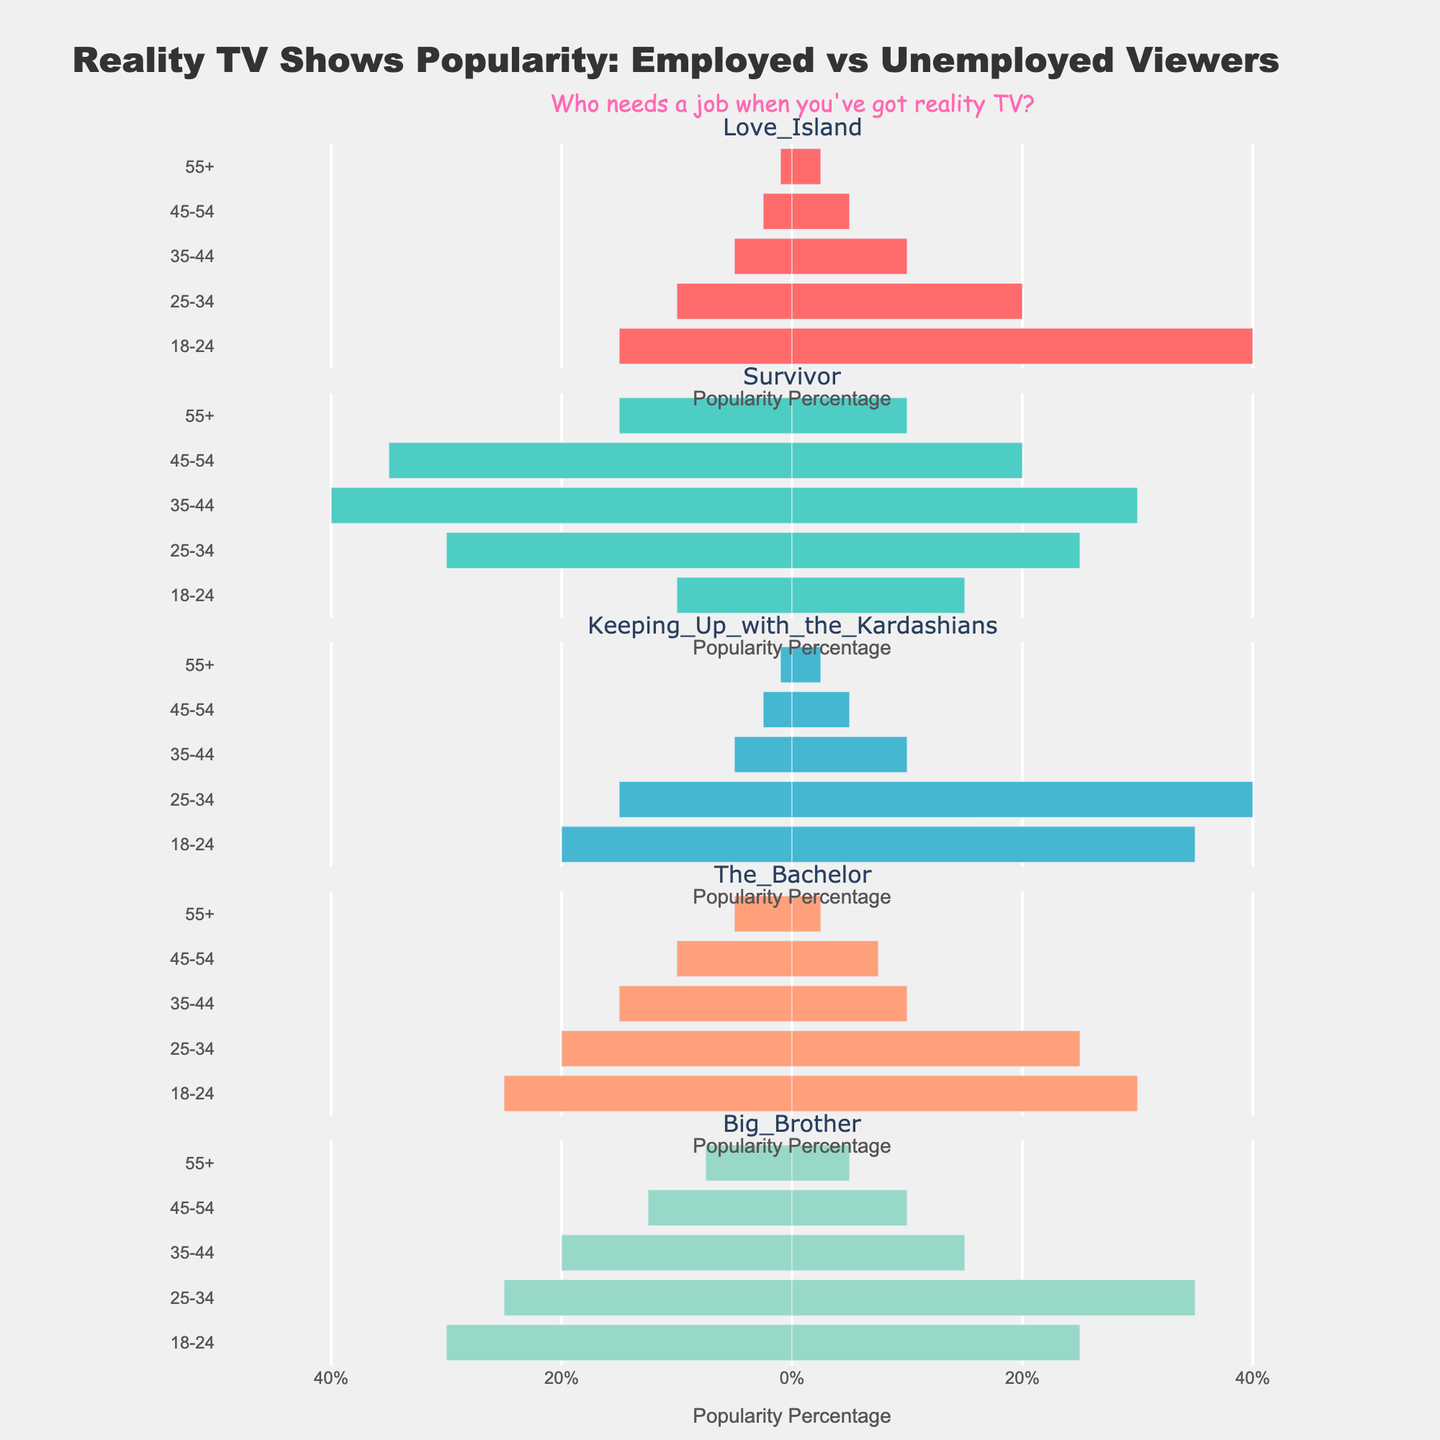What percentage of 18-24-year-olds who are employed watched "The Bachelor"? Find the bar corresponding to "The Bachelor" and 18-24 age group for employed viewers. The height of the bar shows 25%.
Answer: 25% Which age group of unemployed viewers has the highest percentage for "Keeping Up with the Kardashians"? Look at the bars for "Keeping Up with the Kardashians" for all unemployed age groups and find the highest one. "25-34" age group has the highest bar at 40%.
Answer: 25-34 Compare the percentages of employed and unemployed viewers aged 35-44 who watch "Survivor". Which group watches more? Check the bars for "Survivor" at the 35-44 age group. Employed viewers show 40%, while unemployed viewers show 30%. Employed viewers watch more.
Answer: Employed What is the average percentage of viewers aged 18-24 (regardless of job status) who watch "Love Island"? Both employed and unemployed 18-24 viewers for "Love Island" are 15% and 40%. The average is (15 + 40) / 2 = 27.5%.
Answer: 27.5% Which show do unemployed viewers aged 55+ prefer the most? Look at the bars for all shows for unemployed 55+ viewers. "Big Brother" has the highest bar at 5%.
Answer: Big Brother Do employed viewers aged 45-54 prefer "Survivor" or "Big Brother" more? For employed 45-54 age group, compare the bars of "Survivor" (35%) and "Big Brother" (12.5%). "Survivor" is preferred more.
Answer: Survivor What is the difference in percentage between employed and unemployed viewers aged 25-34 who watch "The Bachelor"? Employed viewers aged 25-34 for "The Bachelor" are 20%, and unemployed are 25%. The difference is 25 - 20 = 5%.
Answer: 5% Is there any age group for unemployed viewers where "Keeping Up with the Kardashians" and "Love Island" have the same percentage? Compare the bars of "Keeping Up with the Kardashians" and "Love Island" for all unemployed age groups. At ages 45-54, both have 5%.
Answer: Yes, 45-54 What is the most popular show among employed viewers aged 18-24? Check the bars for employed 18-24 age group. "Big Brother" has the highest percentage at 30%.
Answer: Big Brother In which age group do unemployed viewers have the lowest percentage for "Survivor"? Look at the "Survivor" bars for all unemployed age groups. The 55+ group has the lowest percentage at 10%.
Answer: 55+ 